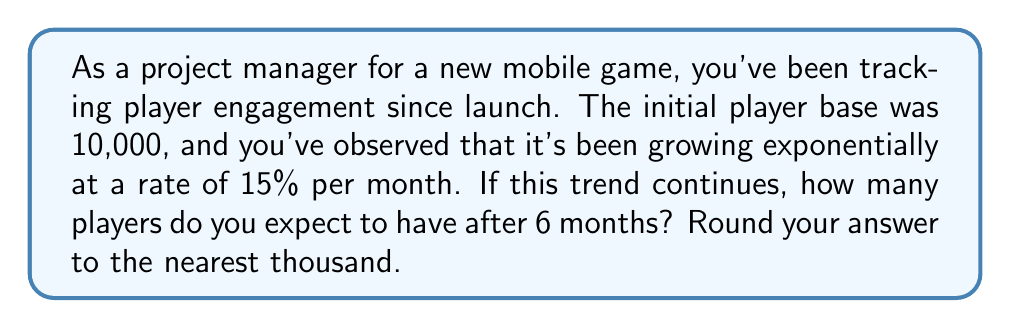What is the answer to this math problem? To solve this problem, we'll use the exponential growth model:

$$A = P(1 + r)^t$$

Where:
$A$ = final amount
$P$ = initial principal (starting amount)
$r$ = growth rate (as a decimal)
$t$ = time period

Given:
$P = 10,000$ (initial player base)
$r = 0.15$ (15% growth rate per month)
$t = 6$ (months)

Let's plug these values into our equation:

$$A = 10,000(1 + 0.15)^6$$

Now, let's solve step by step:

1) First, calculate $(1 + 0.15)^6$:
   $$(1.15)^6 \approx 2.3131$$

2) Multiply this by the initial player base:
   $$A = 10,000 \times 2.3131 = 23,131$$

3) Round to the nearest thousand:
   $$23,131 \approx 23,000$$

Therefore, after 6 months, you can expect approximately 23,000 players if the exponential growth trend continues.
Answer: 23,000 players 